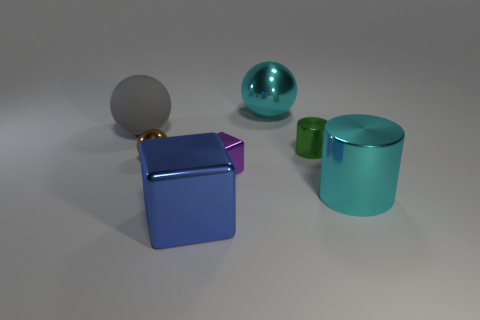There is a large thing that is both in front of the small brown sphere and to the left of the cyan cylinder; what color is it?
Make the answer very short. Blue. What shape is the cyan thing on the right side of the big cyan ball?
Provide a succinct answer. Cylinder. There is a metallic cube that is in front of the cylinder that is in front of the metal cylinder left of the big cylinder; how big is it?
Your answer should be very brief. Large. How many large cyan cylinders are in front of the cyan metallic thing that is in front of the tiny brown object?
Give a very brief answer. 0. There is a metal object that is both behind the tiny ball and in front of the gray object; how big is it?
Your response must be concise. Small. What number of metal objects are either large yellow cubes or large blue things?
Keep it short and to the point. 1. What material is the gray thing?
Offer a very short reply. Rubber. There is a ball left of the brown shiny sphere left of the large sphere that is to the right of the large blue cube; what is its material?
Your answer should be compact. Rubber. What shape is the blue metal object that is the same size as the cyan ball?
Offer a very short reply. Cube. How many things are small blocks or shiny objects on the right side of the blue object?
Your response must be concise. 4. 